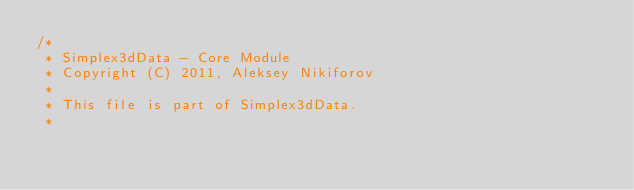Convert code to text. <code><loc_0><loc_0><loc_500><loc_500><_Scala_>/*
 * Simplex3dData - Core Module
 * Copyright (C) 2011, Aleksey Nikiforov
 *
 * This file is part of Simplex3dData.
 *</code> 